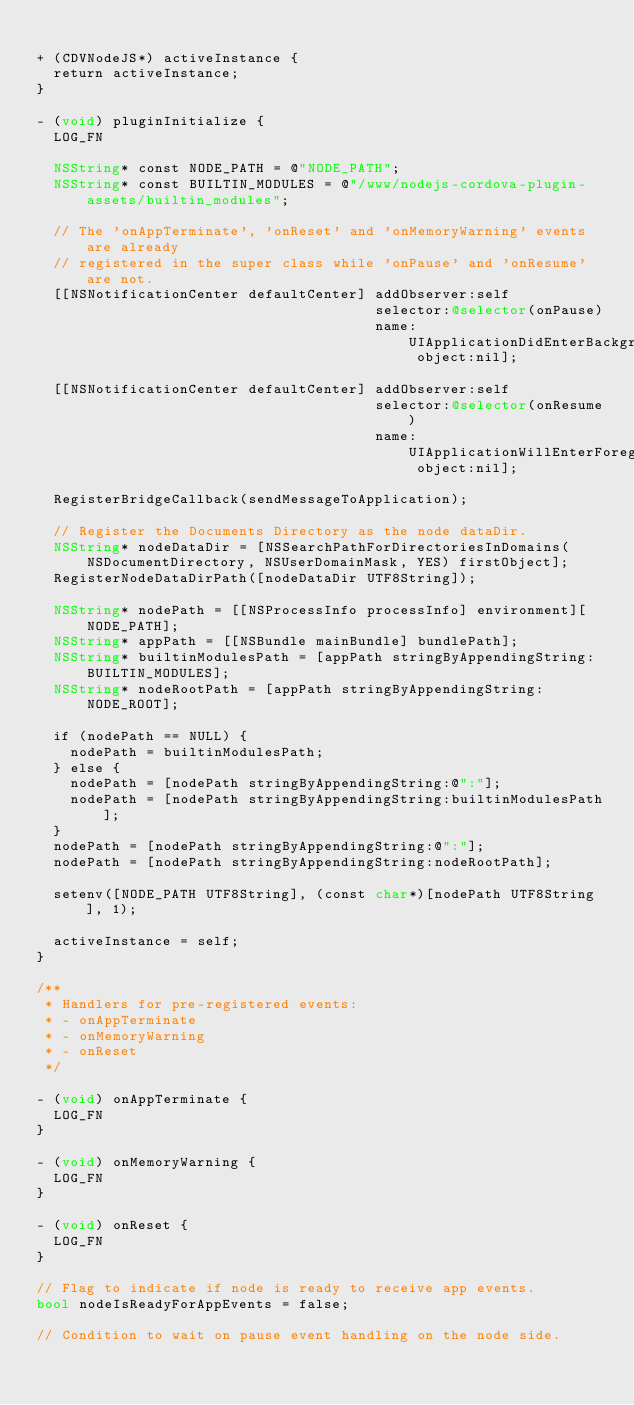<code> <loc_0><loc_0><loc_500><loc_500><_ObjectiveC_>
+ (CDVNodeJS*) activeInstance {
  return activeInstance;
}

- (void) pluginInitialize {
  LOG_FN

  NSString* const NODE_PATH = @"NODE_PATH";
  NSString* const BUILTIN_MODULES = @"/www/nodejs-cordova-plugin-assets/builtin_modules";

  // The 'onAppTerminate', 'onReset' and 'onMemoryWarning' events are already
  // registered in the super class while 'onPause' and 'onResume' are not.
  [[NSNotificationCenter defaultCenter] addObserver:self
                                        selector:@selector(onPause)
                                        name:UIApplicationDidEnterBackgroundNotification object:nil];

  [[NSNotificationCenter defaultCenter] addObserver:self
                                        selector:@selector(onResume)
                                        name:UIApplicationWillEnterForegroundNotification object:nil];

  RegisterBridgeCallback(sendMessageToApplication);

  // Register the Documents Directory as the node dataDir.
  NSString* nodeDataDir = [NSSearchPathForDirectoriesInDomains(NSDocumentDirectory, NSUserDomainMask, YES) firstObject];
  RegisterNodeDataDirPath([nodeDataDir UTF8String]);

  NSString* nodePath = [[NSProcessInfo processInfo] environment][NODE_PATH];
  NSString* appPath = [[NSBundle mainBundle] bundlePath];
  NSString* builtinModulesPath = [appPath stringByAppendingString:BUILTIN_MODULES];
  NSString* nodeRootPath = [appPath stringByAppendingString:NODE_ROOT];

  if (nodePath == NULL) {
    nodePath = builtinModulesPath;
  } else {
    nodePath = [nodePath stringByAppendingString:@":"];
    nodePath = [nodePath stringByAppendingString:builtinModulesPath];
  }
  nodePath = [nodePath stringByAppendingString:@":"];
  nodePath = [nodePath stringByAppendingString:nodeRootPath];

  setenv([NODE_PATH UTF8String], (const char*)[nodePath UTF8String], 1);

  activeInstance = self;
}

/**
 * Handlers for pre-registered events:
 * - onAppTerminate
 * - onMemoryWarning
 * - onReset
 */

- (void) onAppTerminate {
  LOG_FN
}

- (void) onMemoryWarning {
  LOG_FN
}

- (void) onReset {
  LOG_FN
}

// Flag to indicate if node is ready to receive app events.
bool nodeIsReadyForAppEvents = false;

// Condition to wait on pause event handling on the node side.</code> 